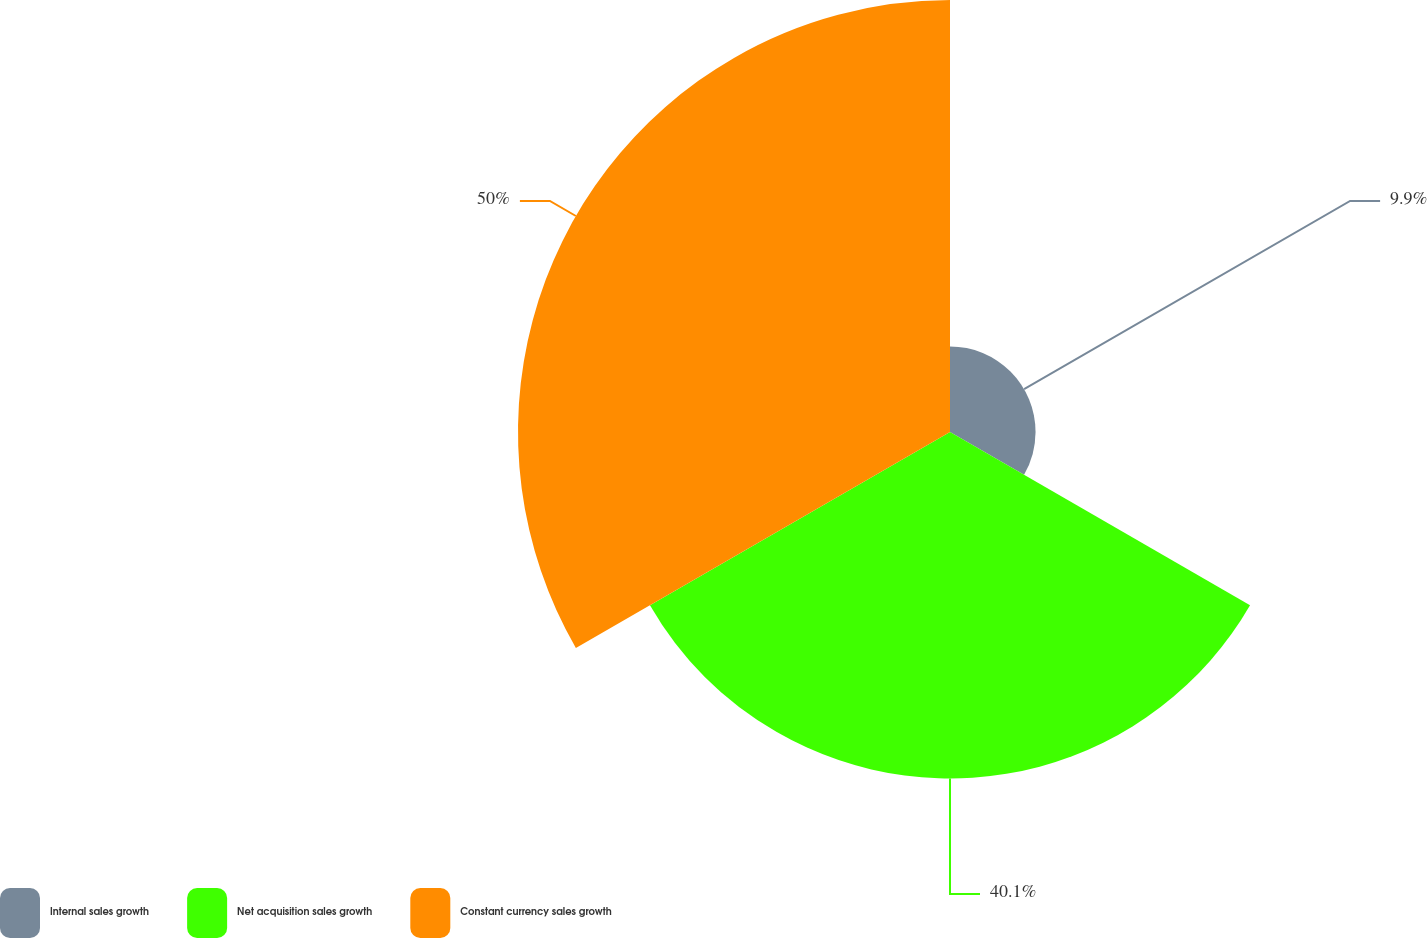Convert chart. <chart><loc_0><loc_0><loc_500><loc_500><pie_chart><fcel>Internal sales growth<fcel>Net acquisition sales growth<fcel>Constant currency sales growth<nl><fcel>9.9%<fcel>40.1%<fcel>50.0%<nl></chart> 